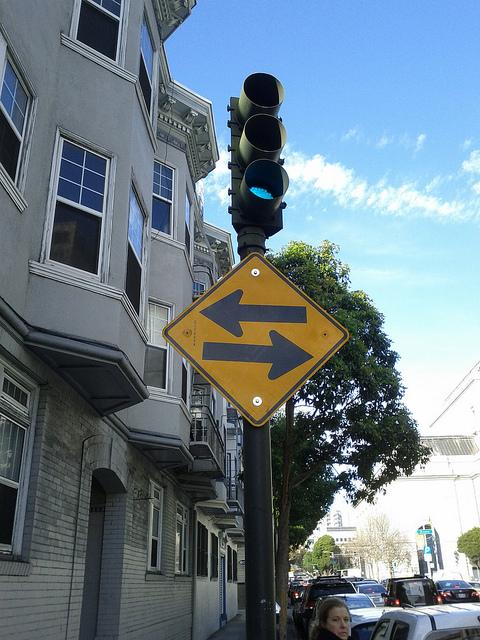Where does the woman stand at?

Choices:
A) front yard
B) highway
C) intersection
D) porch intersection 